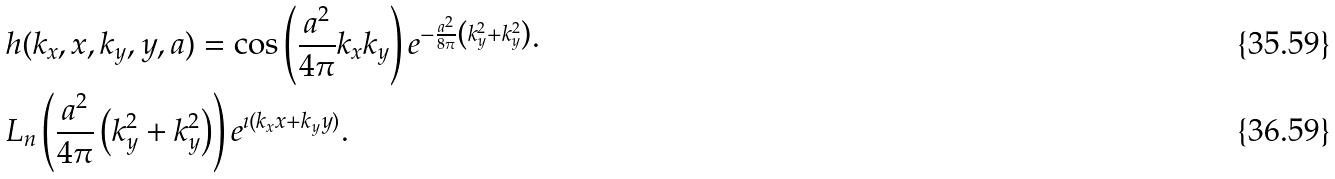<formula> <loc_0><loc_0><loc_500><loc_500>& h ( k _ { x } , x , k _ { y } , y , a ) = \cos \left ( \frac { a ^ { 2 } } { 4 \pi } k _ { x } k _ { y } \right ) e ^ { - \frac { a ^ { 2 } } { 8 \pi } \left ( k _ { y } ^ { 2 } + k _ { y } ^ { 2 } \right ) } \cdot \\ & L _ { n } \left ( \frac { a ^ { 2 } } { 4 \pi } \left ( k _ { y } ^ { 2 } + k _ { y } ^ { 2 } \right ) \right ) e ^ { \imath ( k _ { x } x + k _ { y } y ) } .</formula> 